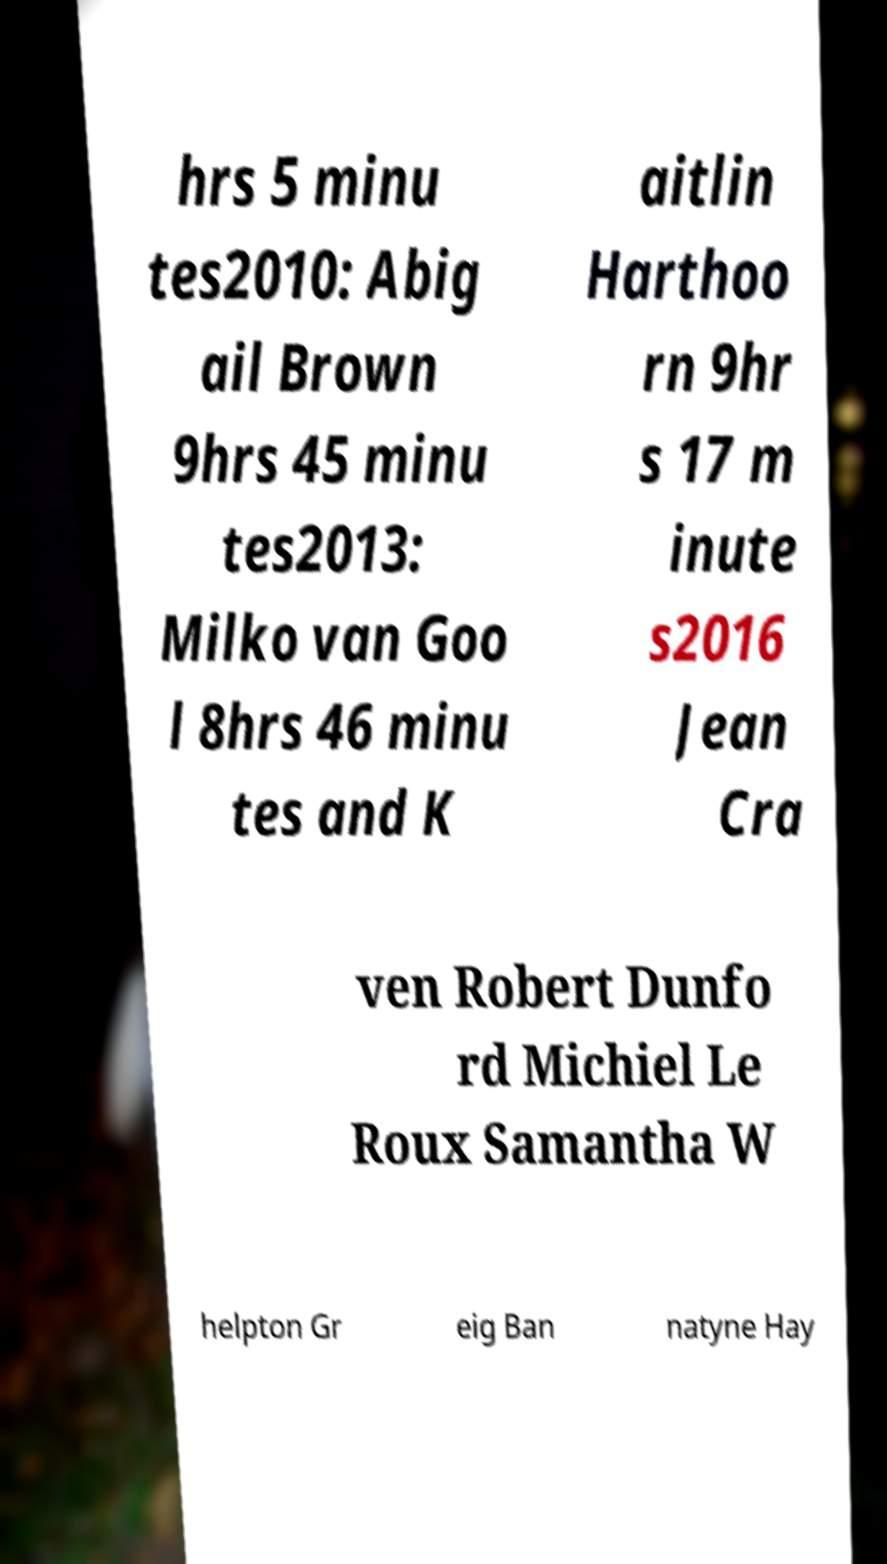I need the written content from this picture converted into text. Can you do that? hrs 5 minu tes2010: Abig ail Brown 9hrs 45 minu tes2013: Milko van Goo l 8hrs 46 minu tes and K aitlin Harthoo rn 9hr s 17 m inute s2016 Jean Cra ven Robert Dunfo rd Michiel Le Roux Samantha W helpton Gr eig Ban natyne Hay 